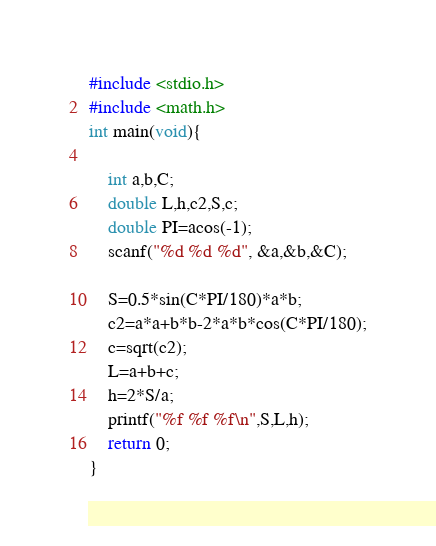<code> <loc_0><loc_0><loc_500><loc_500><_C_>#include <stdio.h>
#include <math.h>
int main(void){

    int a,b,C;
    double L,h,c2,S,c;
    double PI=acos(-1);
    scanf("%d %d %d", &a,&b,&C);
    
    S=0.5*sin(C*PI/180)*a*b;
    c2=a*a+b*b-2*a*b*cos(C*PI/180);
    c=sqrt(c2);
    L=a+b+c;
    h=2*S/a;
    printf("%f %f %f\n",S,L,h);
    return 0;
}

</code> 